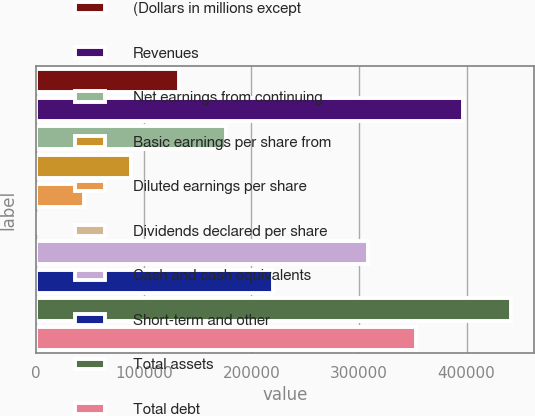<chart> <loc_0><loc_0><loc_500><loc_500><bar_chart><fcel>(Dollars in millions except<fcel>Revenues<fcel>Net earnings from continuing<fcel>Basic earnings per share from<fcel>Diluted earnings per share<fcel>Dividends declared per share<fcel>Cash and cash equivalents<fcel>Short-term and other<fcel>Total assets<fcel>Total debt<nl><fcel>132280<fcel>396835<fcel>176373<fcel>88187.4<fcel>44094.8<fcel>2.19<fcel>308650<fcel>220465<fcel>440928<fcel>352743<nl></chart> 